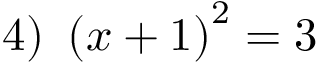Convert formula to latex. <formula><loc_0><loc_0><loc_500><loc_500>4 ) \ \left ( x + 1 \right ) ^ { 2 } = 3</formula> 